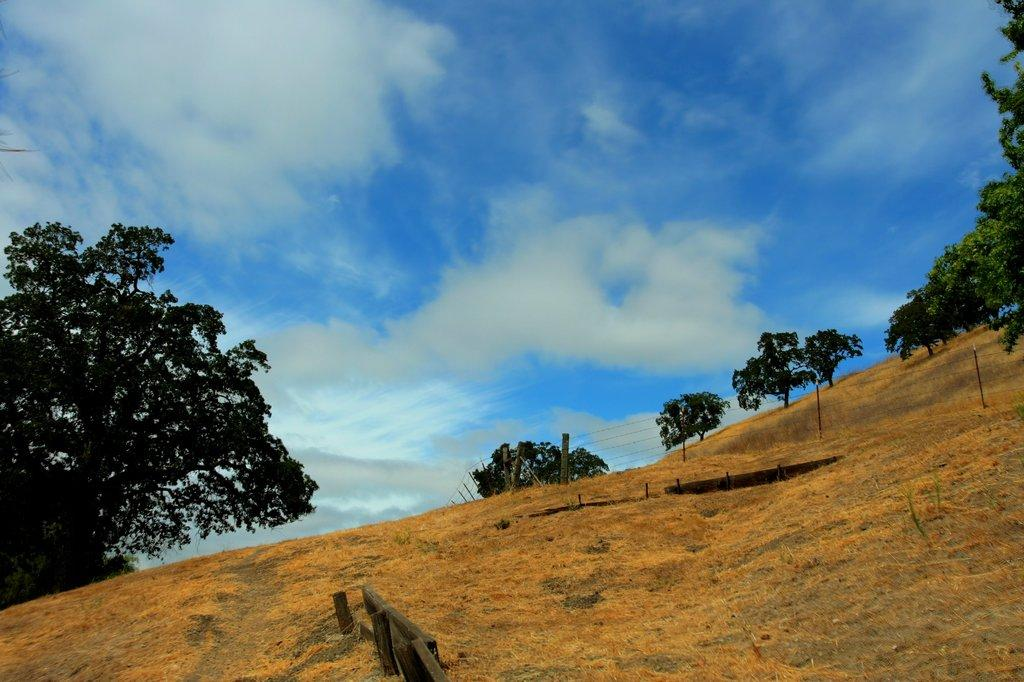What type of vegetation can be seen on the mountain in the image? There are trees on the mountain in the image. What is visible in the background of the image? The sky is visible in the background of the image. What can be observed in the sky? Clouds are present in the sky. What type of tools does the carpenter use in the image? There is no carpenter present in the image. What type of reading material can be seen on the mountain in the image? There are no books or any reading material visible in the image. 